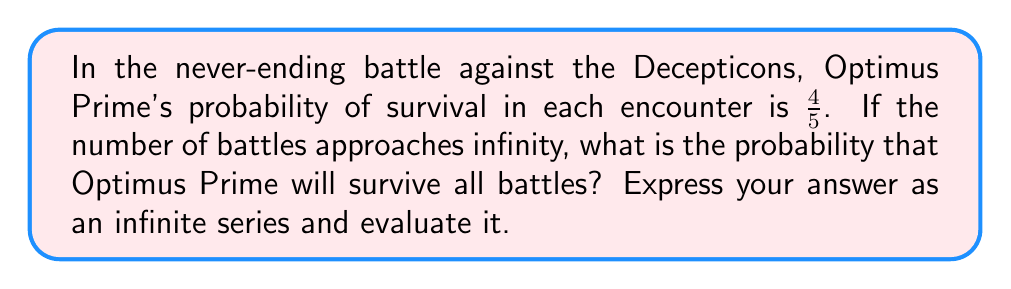Can you answer this question? Let's approach this step-by-step:

1) The probability of Optimus Prime surviving one battle is $\frac{4}{5}$.

2) For two battles, the probability of surviving both is $(\frac{4}{5})^2$.

3) For $n$ battles, the probability of surviving all is $(\frac{4}{5})^n$.

4) As the number of battles approaches infinity, we can represent the probability of surviving all battles as an infinite series:

   $$S = \lim_{n \to \infty} (\frac{4}{5})^n$$

5) This is a geometric series with first term $a=1$ and common ratio $r=\frac{4}{5}$.

6) For an infinite geometric series with $|r| < 1$, the sum is given by the formula:

   $$S = \frac{a}{1-r}$$

7) In this case, $|r| = |\frac{4}{5}| = 0.8 < 1$, so we can use this formula.

8) Substituting our values:

   $$S = \frac{1}{1-\frac{4}{5}} = \frac{1}{\frac{1}{5}} = 5$$

9) However, this result is impossible as a probability cannot exceed 1.

10) The reason for this apparent contradiction is that the probability of surviving an infinite number of battles with any chance of loss in each battle is actually 0.

11) We can see this by calculating the probability of losing at least one battle:

    $$1 - \lim_{n \to \infty} (\frac{4}{5})^n = 1 - 0 = 1$$

Therefore, the probability of surviving all battles as their number approaches infinity is 0.
Answer: 0 